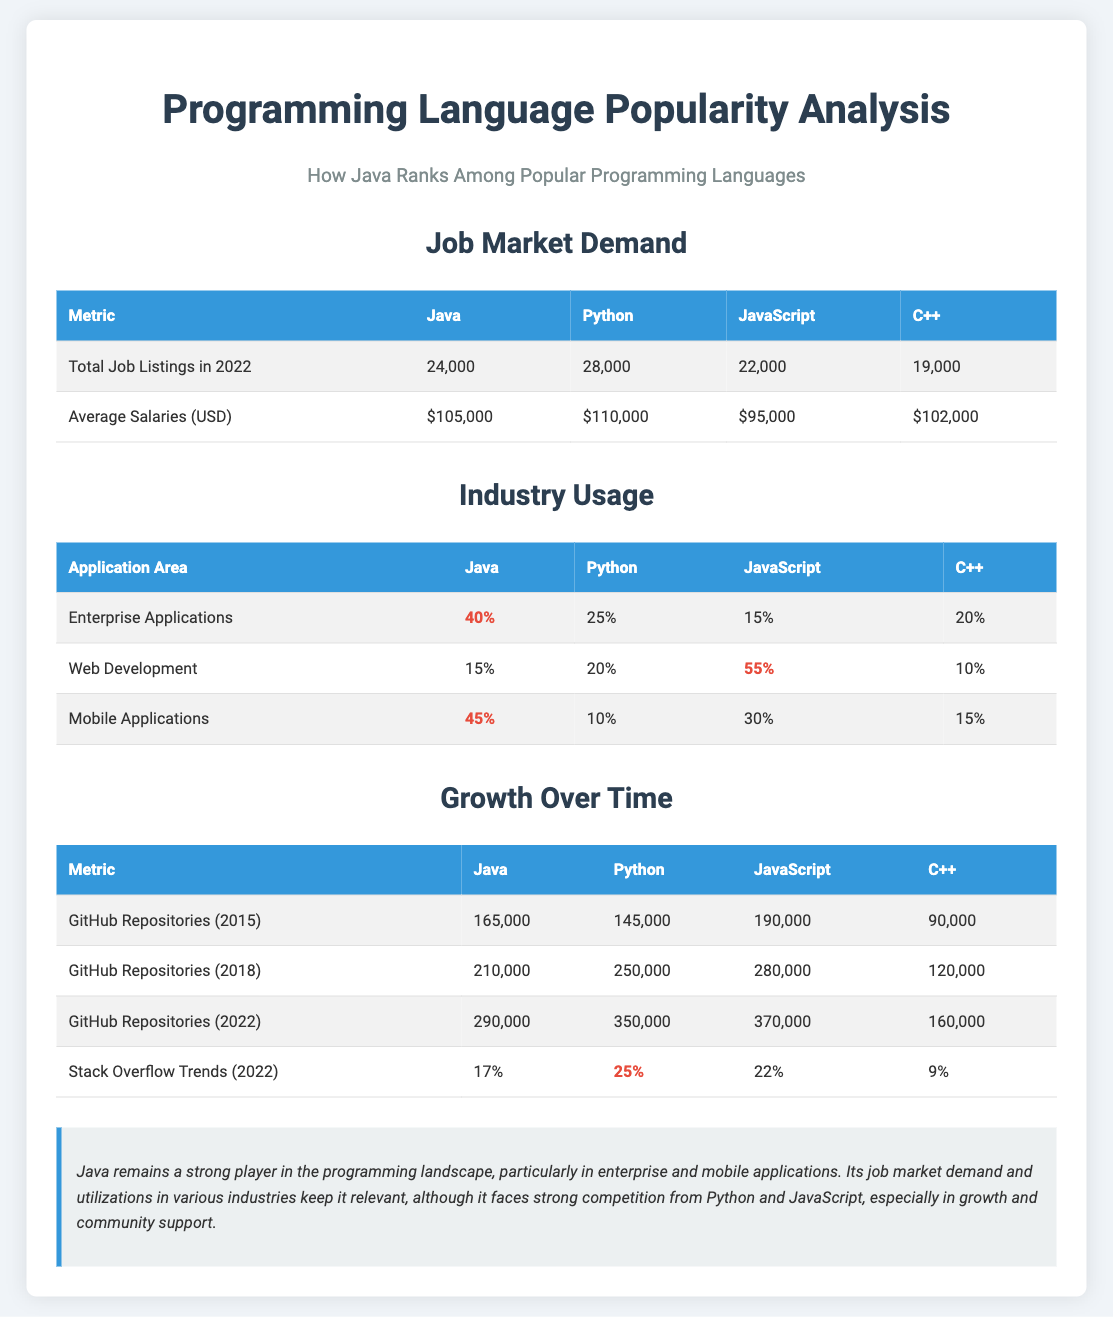What is the total job listings for Java in 2022? The total job listings for Java is explicitly stated as 24,000 in the document.
Answer: 24,000 What is the average salary for Python? The average salary for Python is listed as $110,000 in the table.
Answer: $110,000 What percentage of enterprise applications is built with Java? The document mentions that 40% of enterprise applications use Java.
Answer: 40% What was the number of GitHub repositories for Java in 2018? The document states that in 2018, there were 210,000 GitHub repositories for Java.
Answer: 210,000 Which programming language has the highest job market demand? The job market demand is highest for Python, with 28,000 job listings.
Answer: Python Which application area has Java the highest usage percentage? Java has the highest usage percentage in mobile applications, with 45%.
Answer: Mobile Applications Which programming language is leading in web development usage? JavaScript is highlighted as leading in web development usage with 55%.
Answer: JavaScript What was the Stack Overflow trend percentage for Python in 2022? The Stack Overflow trend for Python in 2022 is noted as 25%.
Answer: 25% What does the conclusion suggest about Java? The conclusion suggests that Java remains strong, particularly in enterprise and mobile applications.
Answer: Strong player 